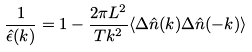<formula> <loc_0><loc_0><loc_500><loc_500>\frac { 1 } { \hat { \epsilon } ( { k } ) } = 1 - \frac { 2 \pi L ^ { 2 } } { T k ^ { 2 } } \langle \Delta \hat { n } ( { k } ) \Delta \hat { n } ( - { k } ) \rangle</formula> 